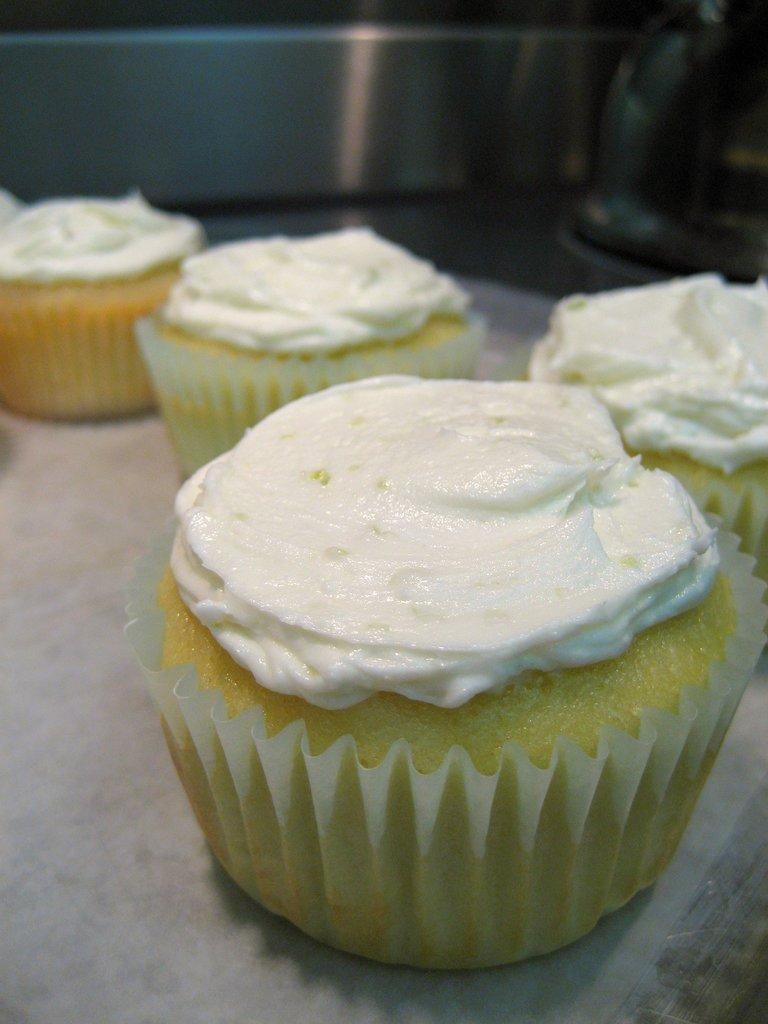What objects are visible in the image? There are cup cons in the image. Where are the cup cons located? The cup cons are placed on a surface. Can you describe the background of the image? The background of the image is not clear. How many wrens can be seen in the image? There are no wrens present in the image. What type of bucket is used to fill the cup cons in the image? There is no bucket visible in the image, and the cup cons are already filled. 